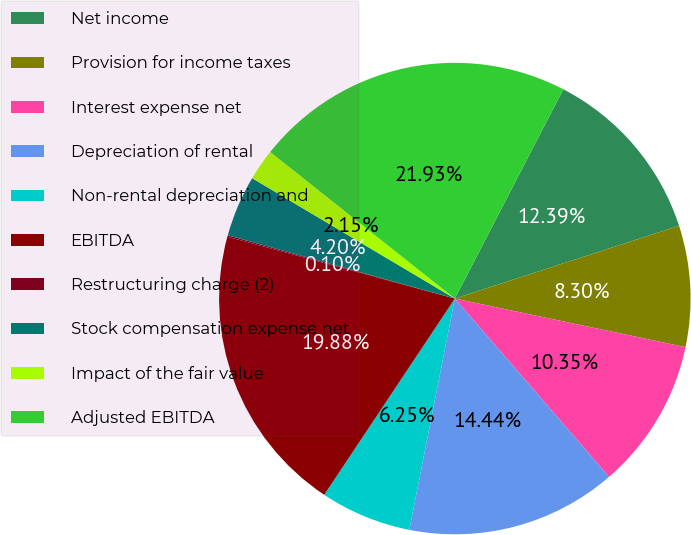Convert chart. <chart><loc_0><loc_0><loc_500><loc_500><pie_chart><fcel>Net income<fcel>Provision for income taxes<fcel>Interest expense net<fcel>Depreciation of rental<fcel>Non-rental depreciation and<fcel>EBITDA<fcel>Restructuring charge (2)<fcel>Stock compensation expense net<fcel>Impact of the fair value<fcel>Adjusted EBITDA<nl><fcel>12.39%<fcel>8.3%<fcel>10.35%<fcel>14.44%<fcel>6.25%<fcel>19.88%<fcel>0.1%<fcel>4.2%<fcel>2.15%<fcel>21.93%<nl></chart> 